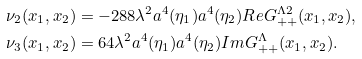Convert formula to latex. <formula><loc_0><loc_0><loc_500><loc_500>\nu _ { 2 } ( x _ { 1 } , x _ { 2 } ) & = - 2 8 8 \lambda ^ { 2 } a ^ { 4 } ( \eta _ { 1 } ) a ^ { 4 } ( \eta _ { 2 } ) R e G ^ { \Lambda 2 } _ { + + } ( x _ { 1 } , x _ { 2 } ) , \\ \nu _ { 3 } ( x _ { 1 } , x _ { 2 } ) & = 6 4 \lambda ^ { 2 } a ^ { 4 } ( \eta _ { 1 } ) a ^ { 4 } ( \eta _ { 2 } ) I m G ^ { \Lambda } _ { + + } ( x _ { 1 } , x _ { 2 } ) .</formula> 